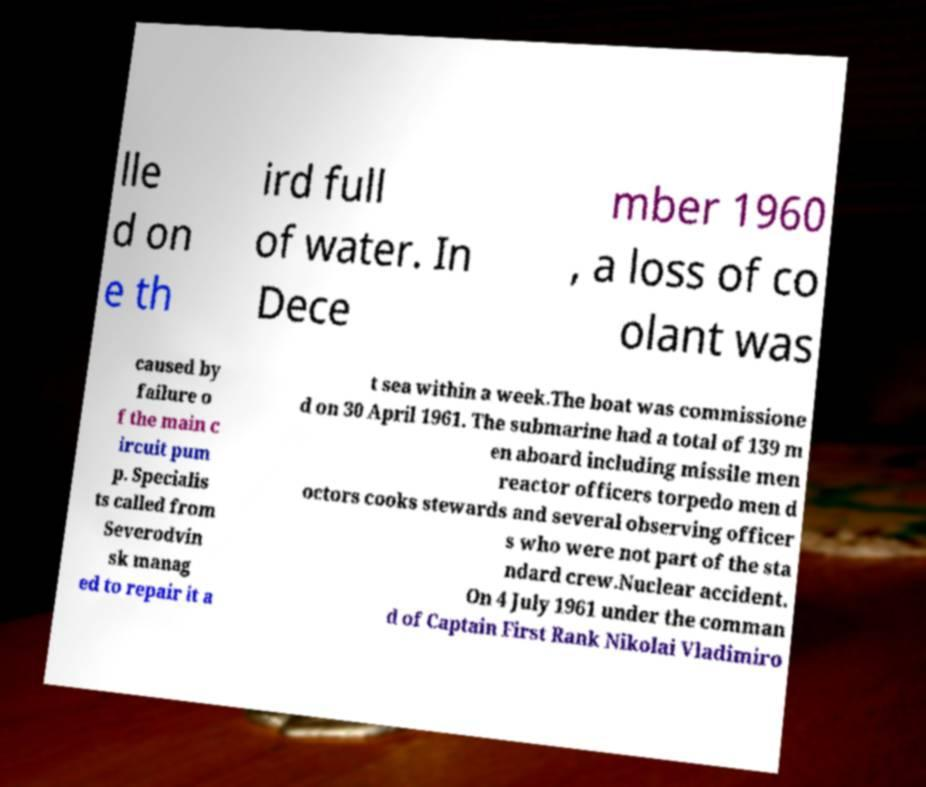I need the written content from this picture converted into text. Can you do that? lle d on e th ird full of water. In Dece mber 1960 , a loss of co olant was caused by failure o f the main c ircuit pum p. Specialis ts called from Severodvin sk manag ed to repair it a t sea within a week.The boat was commissione d on 30 April 1961. The submarine had a total of 139 m en aboard including missile men reactor officers torpedo men d octors cooks stewards and several observing officer s who were not part of the sta ndard crew.Nuclear accident. On 4 July 1961 under the comman d of Captain First Rank Nikolai Vladimiro 